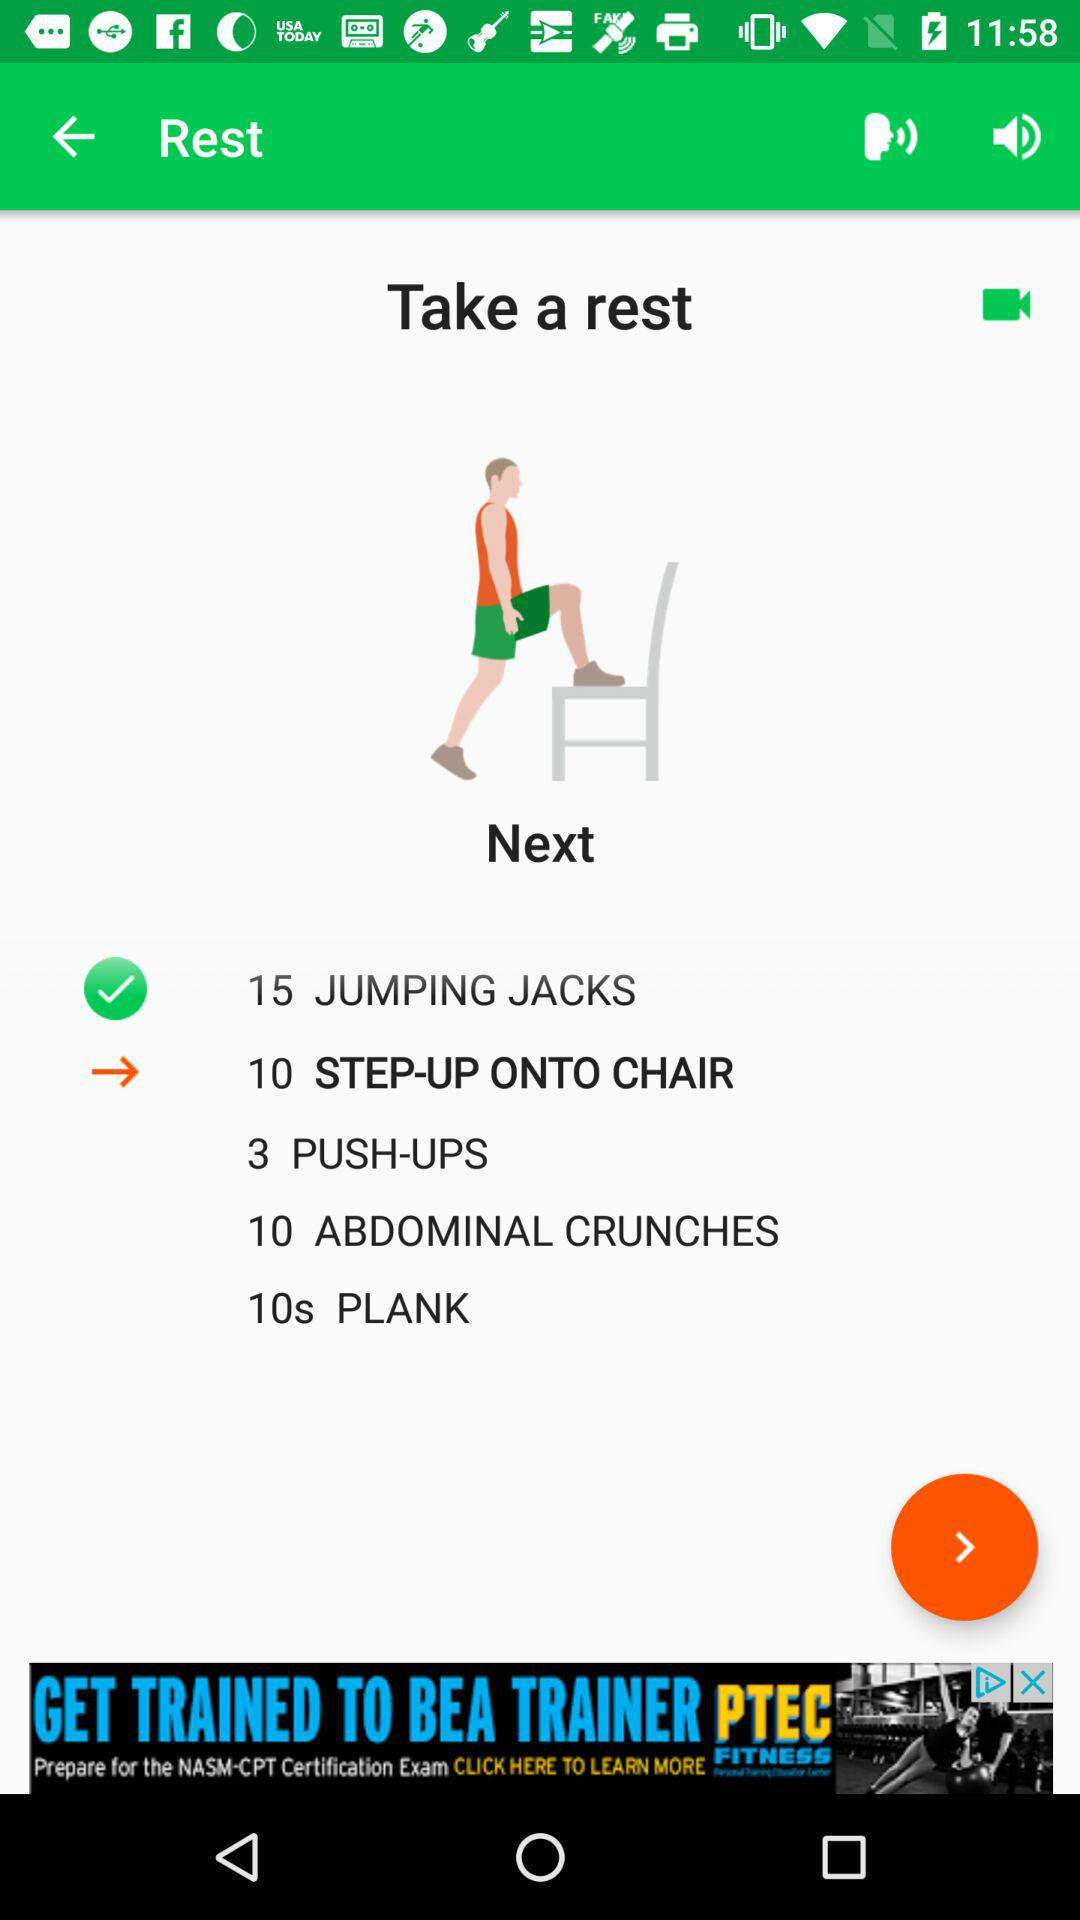How many abdominal crunches are there in the workout?
Answer the question using a single word or phrase. 10 